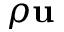<formula> <loc_0><loc_0><loc_500><loc_500>\rho u</formula> 